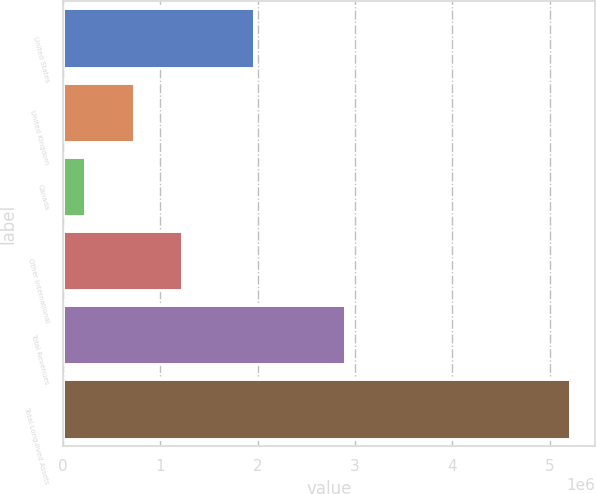Convert chart. <chart><loc_0><loc_0><loc_500><loc_500><bar_chart><fcel>United States<fcel>United Kingdom<fcel>Canada<fcel>Other International<fcel>Total Revenues<fcel>Total Long-lived Assets<nl><fcel>1.95882e+06<fcel>728722<fcel>231477<fcel>1.22597e+06<fcel>2.89235e+06<fcel>5.20393e+06<nl></chart> 